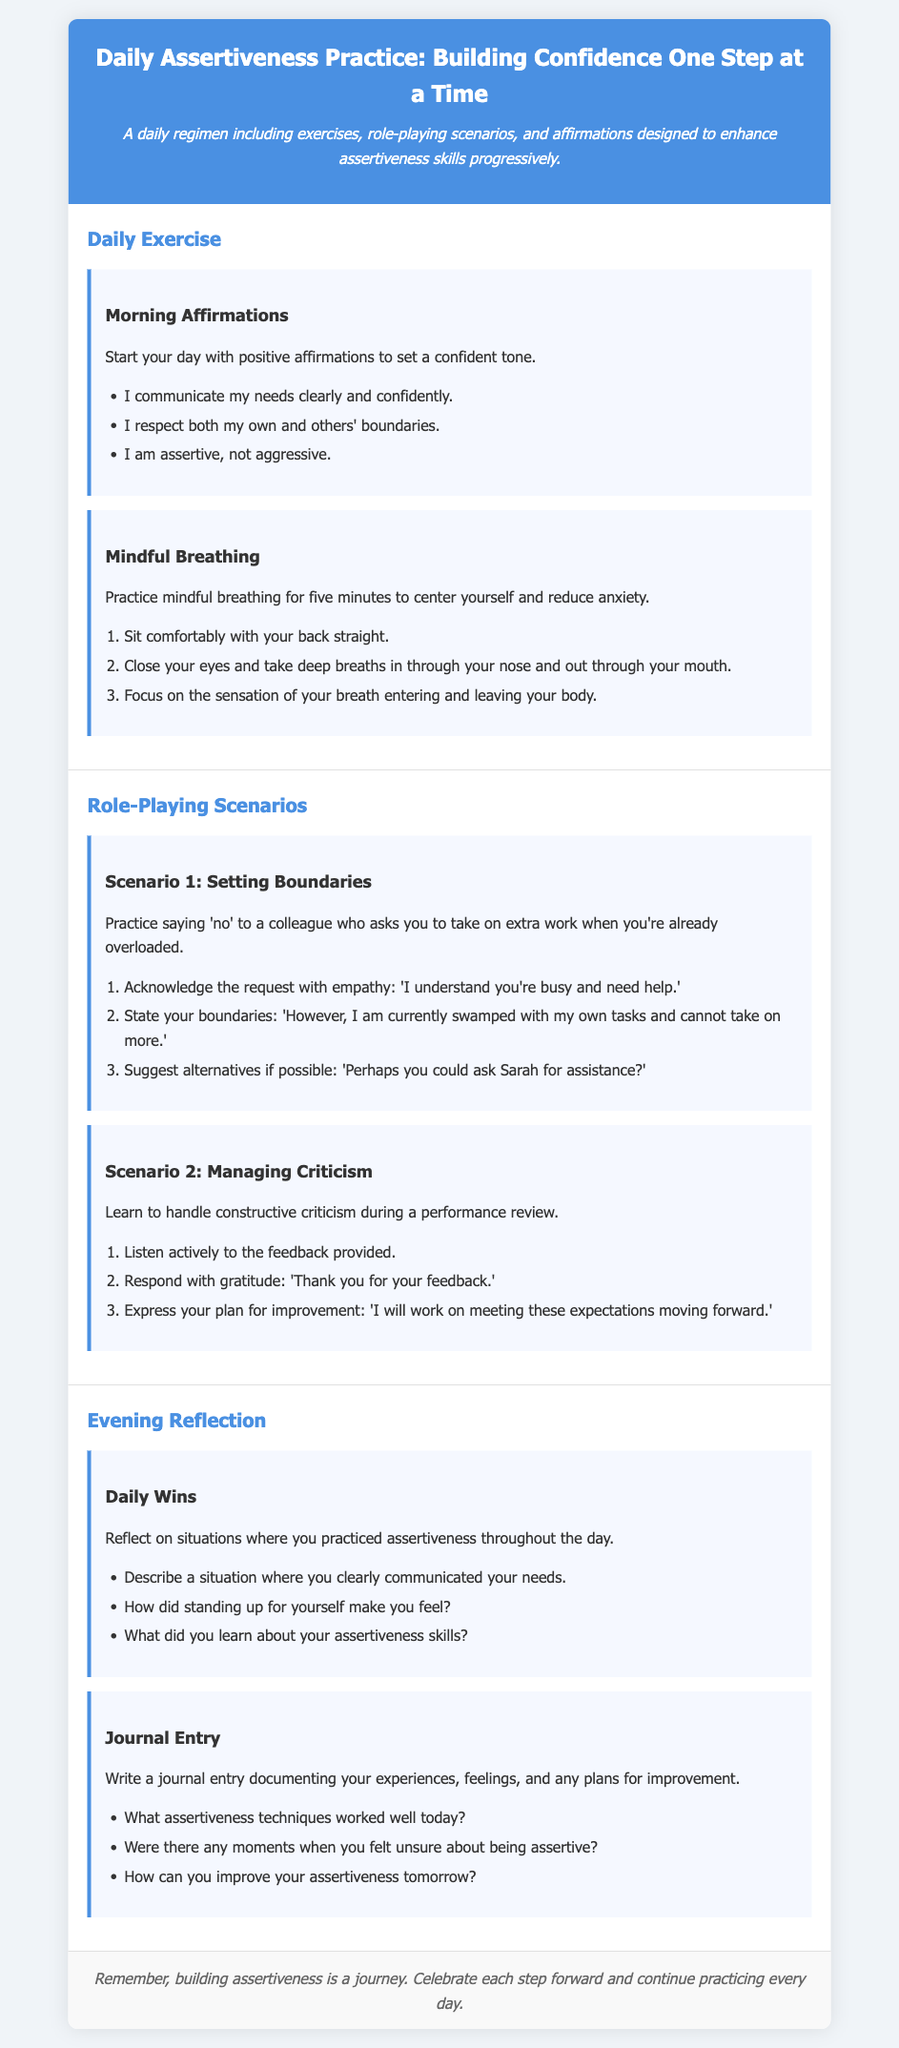what is the title of the regimen? The title of the regimen is prominently displayed at the top of the document, which is "Daily Assertiveness Practice: Building Confidence One Step at a Time."
Answer: Daily Assertiveness Practice: Building Confidence One Step at a Time how many categories are in the document? The document is divided into three main sections: Daily Exercise, Role-Playing Scenarios, and Evening Reflection, totaling three categories.
Answer: 3 what is the first morning affirmation listed? The first morning affirmation is the initial point in the list provided under the Morning Affirmations section.
Answer: I communicate my needs clearly and confidently how long should you practice mindful breathing? The recommended time for practicing mindful breathing is mentioned in the description within that section.
Answer: five minutes what action should you take in Scenario 1 when asked to take on extra work? The document elaborates on what to do when someone requests additional help in this particular scenario.
Answer: State your boundaries which phrase expresses gratitude in Scenario 2? The document provides a specific response within Scenario 2 that demonstrates gratitude towards feedback received.
Answer: Thank you for your feedback how does the document suggest you reflect on your assertiveness daily? The document specifies a method for reflection concerning assertiveness through journal entries after the day ends.
Answer: Journal Entry what should you do if you feel unsure about being assertive? The document indicates an aspect to consider for improvement if feelings of uncertainty arise about assertiveness.
Answer: How can you improve your assertiveness tomorrow? 